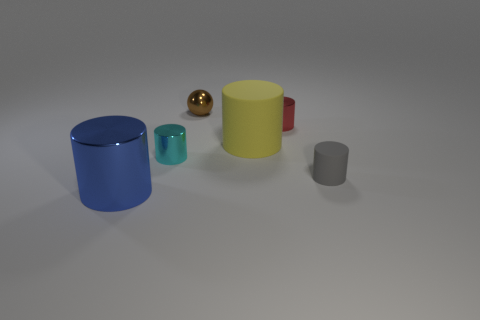How many other objects are there of the same shape as the cyan thing? There are two other objects with a cylindrical shape similar to the cyan-colored cylinder. One is blue and larger, positioned to the left, and the other one is yellow and of similar size, found to the right of the cyan cylinder. 